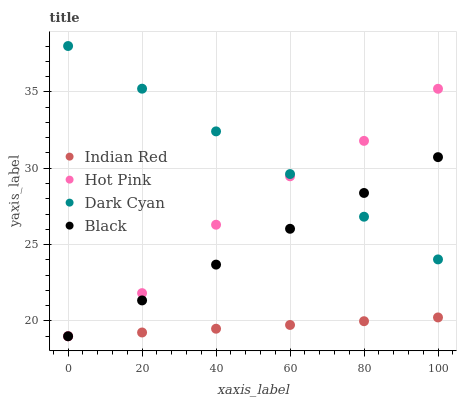Does Indian Red have the minimum area under the curve?
Answer yes or no. Yes. Does Dark Cyan have the maximum area under the curve?
Answer yes or no. Yes. Does Hot Pink have the minimum area under the curve?
Answer yes or no. No. Does Hot Pink have the maximum area under the curve?
Answer yes or no. No. Is Indian Red the smoothest?
Answer yes or no. Yes. Is Hot Pink the roughest?
Answer yes or no. Yes. Is Black the smoothest?
Answer yes or no. No. Is Black the roughest?
Answer yes or no. No. Does Hot Pink have the lowest value?
Answer yes or no. Yes. Does Dark Cyan have the highest value?
Answer yes or no. Yes. Does Hot Pink have the highest value?
Answer yes or no. No. Is Indian Red less than Dark Cyan?
Answer yes or no. Yes. Is Dark Cyan greater than Indian Red?
Answer yes or no. Yes. Does Indian Red intersect Hot Pink?
Answer yes or no. Yes. Is Indian Red less than Hot Pink?
Answer yes or no. No. Is Indian Red greater than Hot Pink?
Answer yes or no. No. Does Indian Red intersect Dark Cyan?
Answer yes or no. No. 